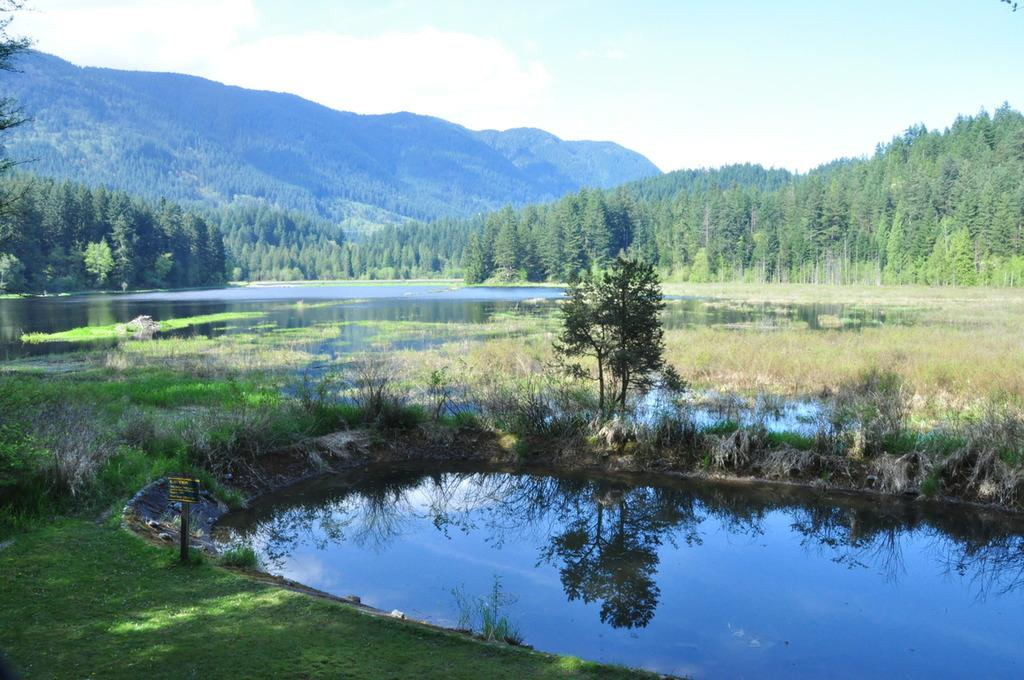What is the primary element visible in the image? There is water in the image. What type of vegetation can be seen in the image? There are plants, grass, and a tree in the image. What is visible in the background of the image? There are trees and hills in the background of the image, along with the sky. Where is the tent located in the image? There is no tent present in the image. What date is marked on the calendar in the image? There is no calendar present in the image. 